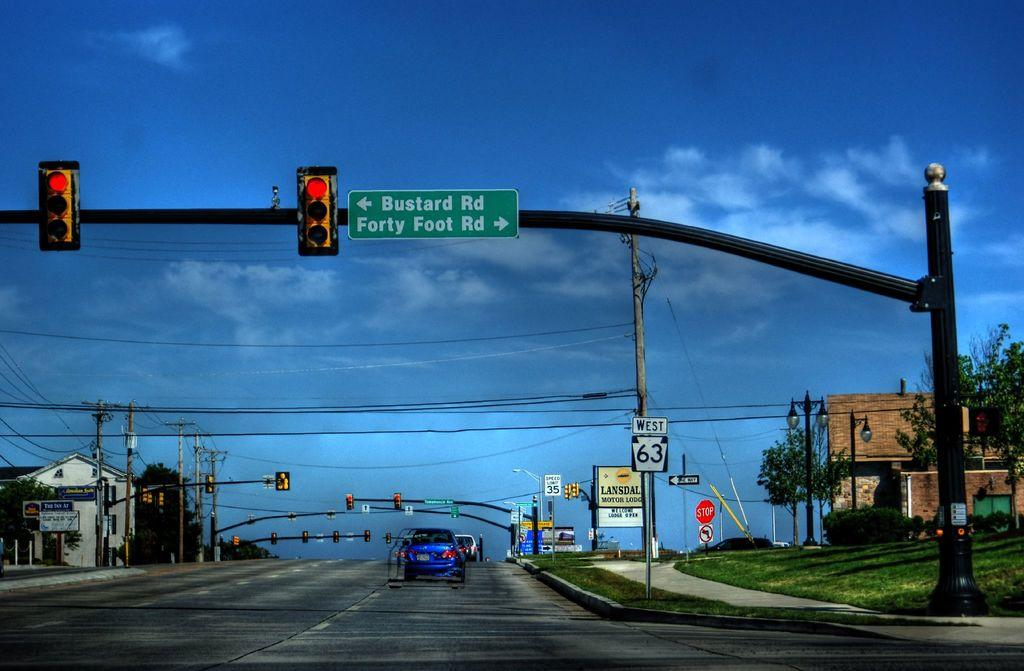<image>
Present a compact description of the photo's key features. A traffic light has street signs mounted for Bustard RD and Forty Foot RD. 